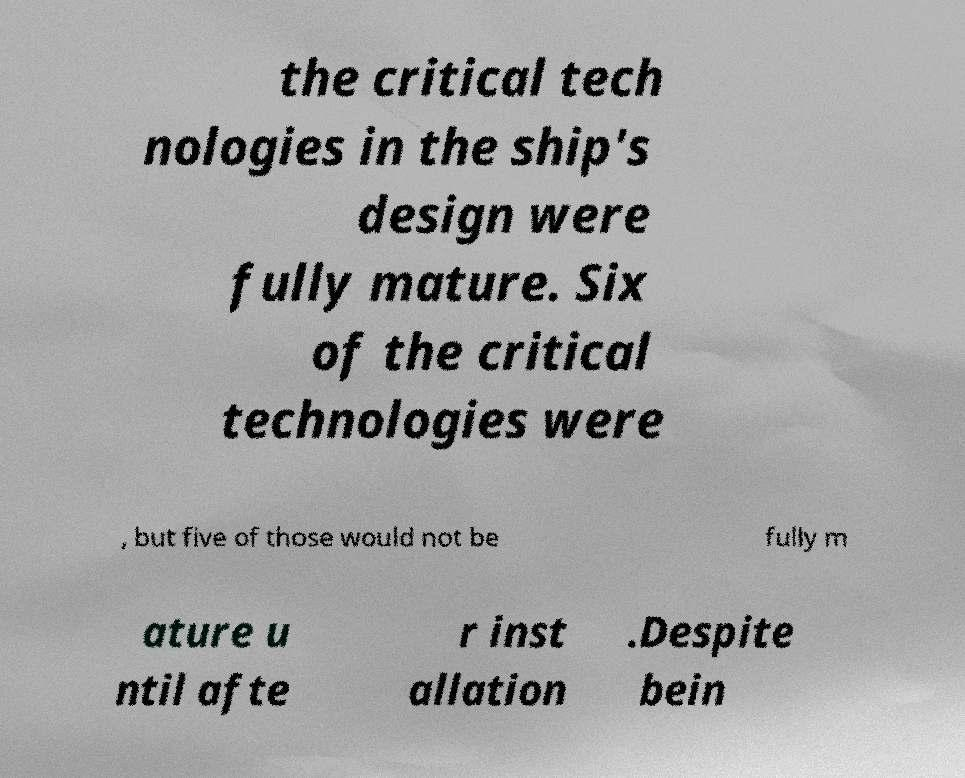I need the written content from this picture converted into text. Can you do that? the critical tech nologies in the ship's design were fully mature. Six of the critical technologies were , but five of those would not be fully m ature u ntil afte r inst allation .Despite bein 